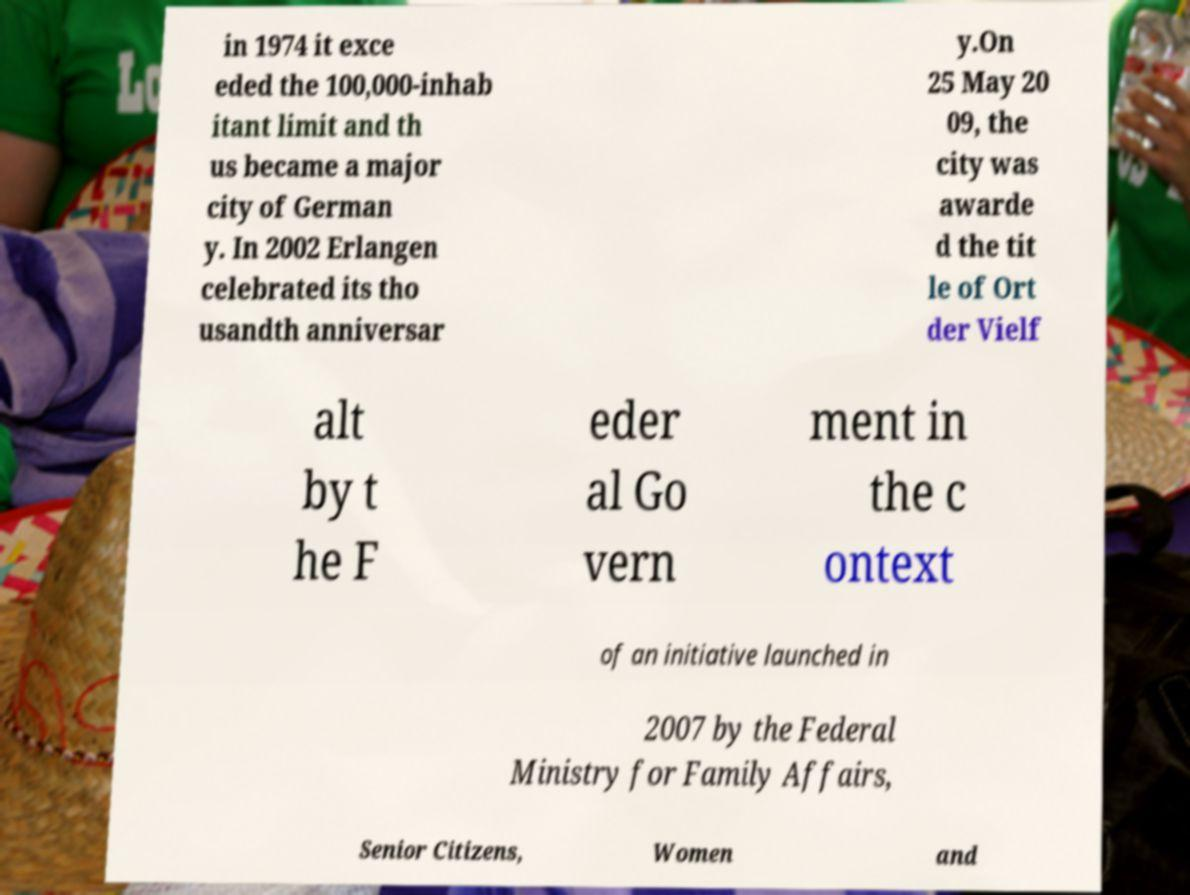There's text embedded in this image that I need extracted. Can you transcribe it verbatim? in 1974 it exce eded the 100,000-inhab itant limit and th us became a major city of German y. In 2002 Erlangen celebrated its tho usandth anniversar y.On 25 May 20 09, the city was awarde d the tit le of Ort der Vielf alt by t he F eder al Go vern ment in the c ontext of an initiative launched in 2007 by the Federal Ministry for Family Affairs, Senior Citizens, Women and 